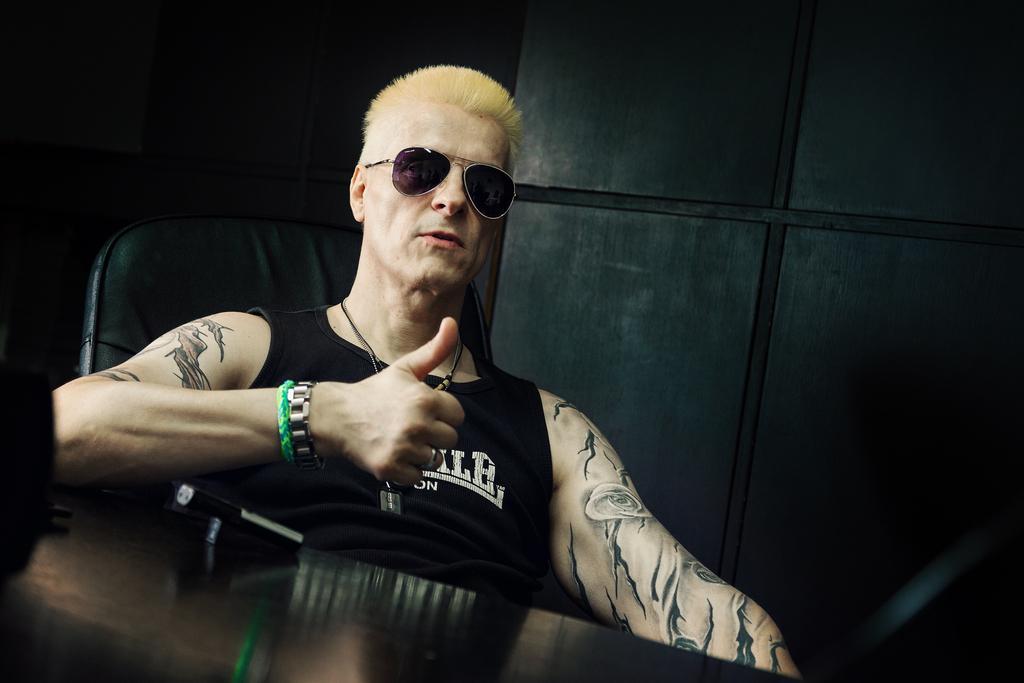Can you describe this image briefly? A man is sitting on the chair, he wore a black color t-shirt, goggles and he is showing his thumb. 